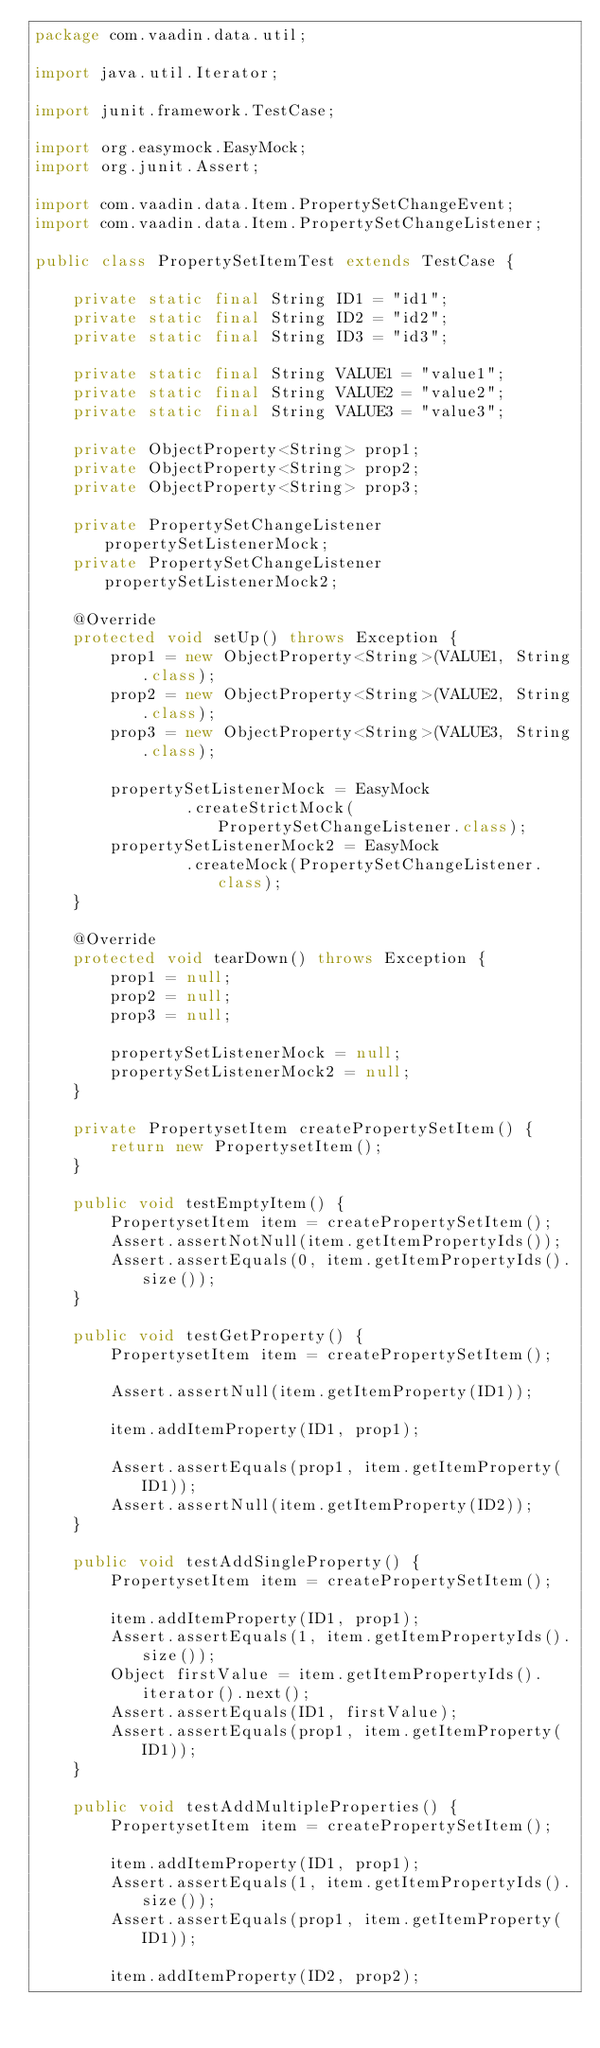<code> <loc_0><loc_0><loc_500><loc_500><_Java_>package com.vaadin.data.util;

import java.util.Iterator;

import junit.framework.TestCase;

import org.easymock.EasyMock;
import org.junit.Assert;

import com.vaadin.data.Item.PropertySetChangeEvent;
import com.vaadin.data.Item.PropertySetChangeListener;

public class PropertySetItemTest extends TestCase {

    private static final String ID1 = "id1";
    private static final String ID2 = "id2";
    private static final String ID3 = "id3";

    private static final String VALUE1 = "value1";
    private static final String VALUE2 = "value2";
    private static final String VALUE3 = "value3";

    private ObjectProperty<String> prop1;
    private ObjectProperty<String> prop2;
    private ObjectProperty<String> prop3;

    private PropertySetChangeListener propertySetListenerMock;
    private PropertySetChangeListener propertySetListenerMock2;

    @Override
    protected void setUp() throws Exception {
        prop1 = new ObjectProperty<String>(VALUE1, String.class);
        prop2 = new ObjectProperty<String>(VALUE2, String.class);
        prop3 = new ObjectProperty<String>(VALUE3, String.class);

        propertySetListenerMock = EasyMock
                .createStrictMock(PropertySetChangeListener.class);
        propertySetListenerMock2 = EasyMock
                .createMock(PropertySetChangeListener.class);
    }

    @Override
    protected void tearDown() throws Exception {
        prop1 = null;
        prop2 = null;
        prop3 = null;

        propertySetListenerMock = null;
        propertySetListenerMock2 = null;
    }

    private PropertysetItem createPropertySetItem() {
        return new PropertysetItem();
    }

    public void testEmptyItem() {
        PropertysetItem item = createPropertySetItem();
        Assert.assertNotNull(item.getItemPropertyIds());
        Assert.assertEquals(0, item.getItemPropertyIds().size());
    }

    public void testGetProperty() {
        PropertysetItem item = createPropertySetItem();

        Assert.assertNull(item.getItemProperty(ID1));

        item.addItemProperty(ID1, prop1);

        Assert.assertEquals(prop1, item.getItemProperty(ID1));
        Assert.assertNull(item.getItemProperty(ID2));
    }

    public void testAddSingleProperty() {
        PropertysetItem item = createPropertySetItem();

        item.addItemProperty(ID1, prop1);
        Assert.assertEquals(1, item.getItemPropertyIds().size());
        Object firstValue = item.getItemPropertyIds().iterator().next();
        Assert.assertEquals(ID1, firstValue);
        Assert.assertEquals(prop1, item.getItemProperty(ID1));
    }

    public void testAddMultipleProperties() {
        PropertysetItem item = createPropertySetItem();

        item.addItemProperty(ID1, prop1);
        Assert.assertEquals(1, item.getItemPropertyIds().size());
        Assert.assertEquals(prop1, item.getItemProperty(ID1));

        item.addItemProperty(ID2, prop2);</code> 